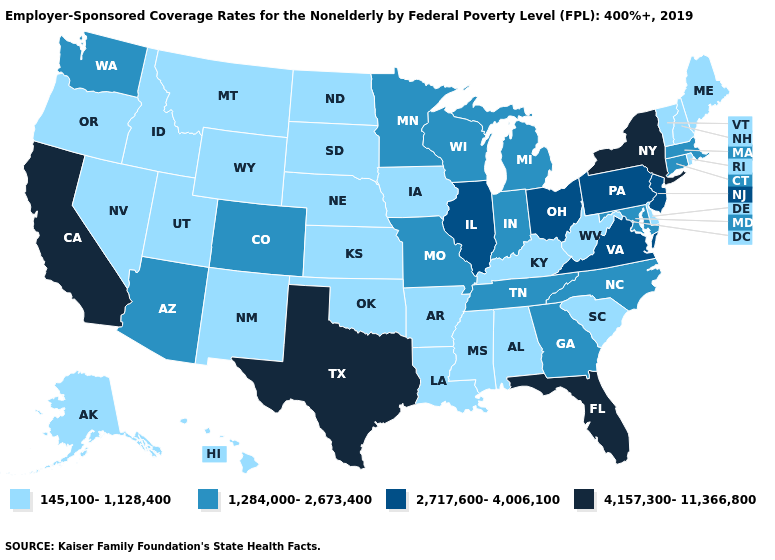Among the states that border Delaware , does New Jersey have the highest value?
Keep it brief. Yes. Among the states that border Delaware , does New Jersey have the highest value?
Keep it brief. Yes. What is the lowest value in states that border Vermont?
Keep it brief. 145,100-1,128,400. Name the states that have a value in the range 2,717,600-4,006,100?
Give a very brief answer. Illinois, New Jersey, Ohio, Pennsylvania, Virginia. Does Oregon have the lowest value in the West?
Quick response, please. Yes. What is the highest value in the West ?
Give a very brief answer. 4,157,300-11,366,800. What is the highest value in states that border Connecticut?
Concise answer only. 4,157,300-11,366,800. Name the states that have a value in the range 1,284,000-2,673,400?
Be succinct. Arizona, Colorado, Connecticut, Georgia, Indiana, Maryland, Massachusetts, Michigan, Minnesota, Missouri, North Carolina, Tennessee, Washington, Wisconsin. Which states have the lowest value in the USA?
Quick response, please. Alabama, Alaska, Arkansas, Delaware, Hawaii, Idaho, Iowa, Kansas, Kentucky, Louisiana, Maine, Mississippi, Montana, Nebraska, Nevada, New Hampshire, New Mexico, North Dakota, Oklahoma, Oregon, Rhode Island, South Carolina, South Dakota, Utah, Vermont, West Virginia, Wyoming. What is the lowest value in states that border Florida?
Answer briefly. 145,100-1,128,400. Which states have the lowest value in the Northeast?
Be succinct. Maine, New Hampshire, Rhode Island, Vermont. What is the value of Maryland?
Concise answer only. 1,284,000-2,673,400. Which states have the lowest value in the USA?
Be succinct. Alabama, Alaska, Arkansas, Delaware, Hawaii, Idaho, Iowa, Kansas, Kentucky, Louisiana, Maine, Mississippi, Montana, Nebraska, Nevada, New Hampshire, New Mexico, North Dakota, Oklahoma, Oregon, Rhode Island, South Carolina, South Dakota, Utah, Vermont, West Virginia, Wyoming. Name the states that have a value in the range 1,284,000-2,673,400?
Be succinct. Arizona, Colorado, Connecticut, Georgia, Indiana, Maryland, Massachusetts, Michigan, Minnesota, Missouri, North Carolina, Tennessee, Washington, Wisconsin. What is the lowest value in the USA?
Be succinct. 145,100-1,128,400. 